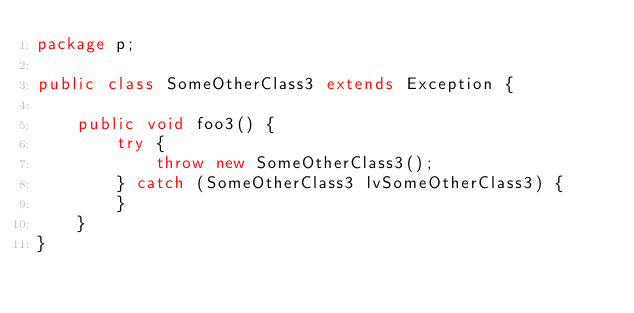Convert code to text. <code><loc_0><loc_0><loc_500><loc_500><_Java_>package p;

public class SomeOtherClass3 extends Exception {

    public void foo3() {
        try {
            throw new SomeOtherClass3();
        } catch (SomeOtherClass3 lvSomeOtherClass3) {
        }
    }
}
</code> 